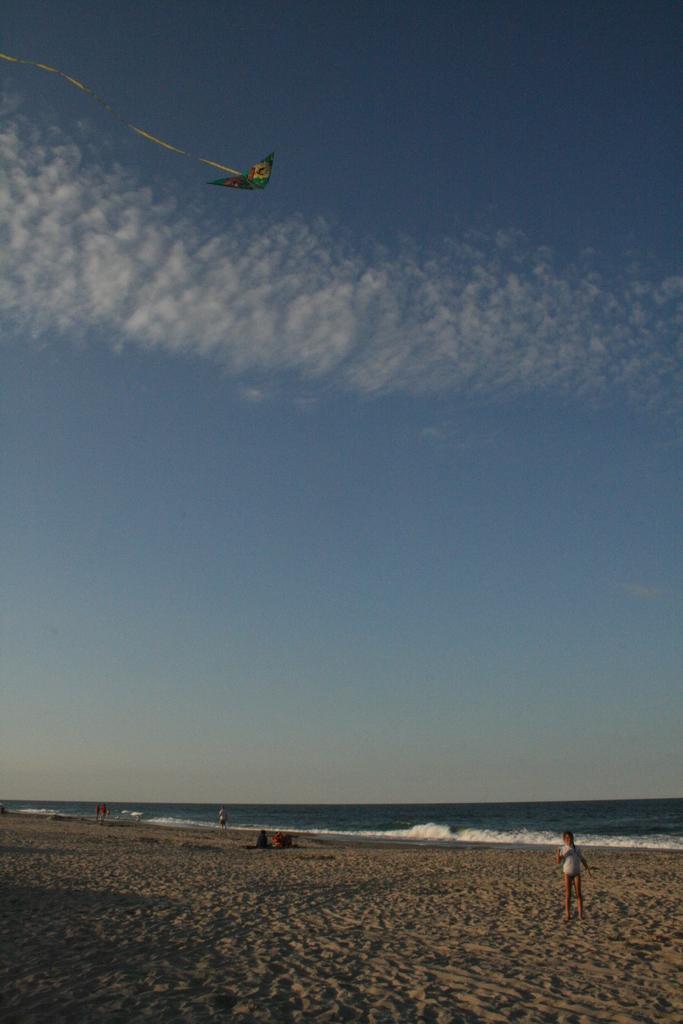Can you describe this image briefly? There is a child standing on the sand surface of a ground. In the background, there are persons, tides of an ocean, there is a kite in the air and there are clouds in the blue sky. 